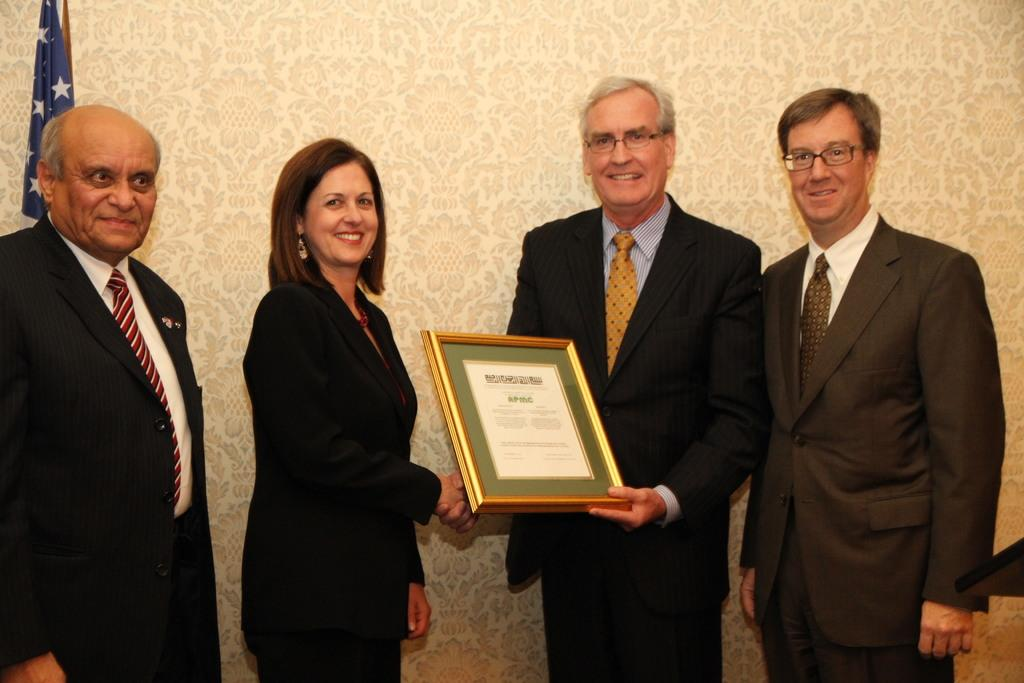How many people are in the image? There are four persons in the image. What are the people wearing? All four persons are wearing black suits. What are the man and woman holding in the image? The man and woman are holding a frame. What can be seen in the background of the image? There is a wall in the background of the image. Where is the flag located in the image? The flag is to the left of the image. What brand of toothpaste is visible on the table in the image? There is no toothpaste present in the image. How many dogs are sitting next to the people in the image? There are no dogs present in the image. 